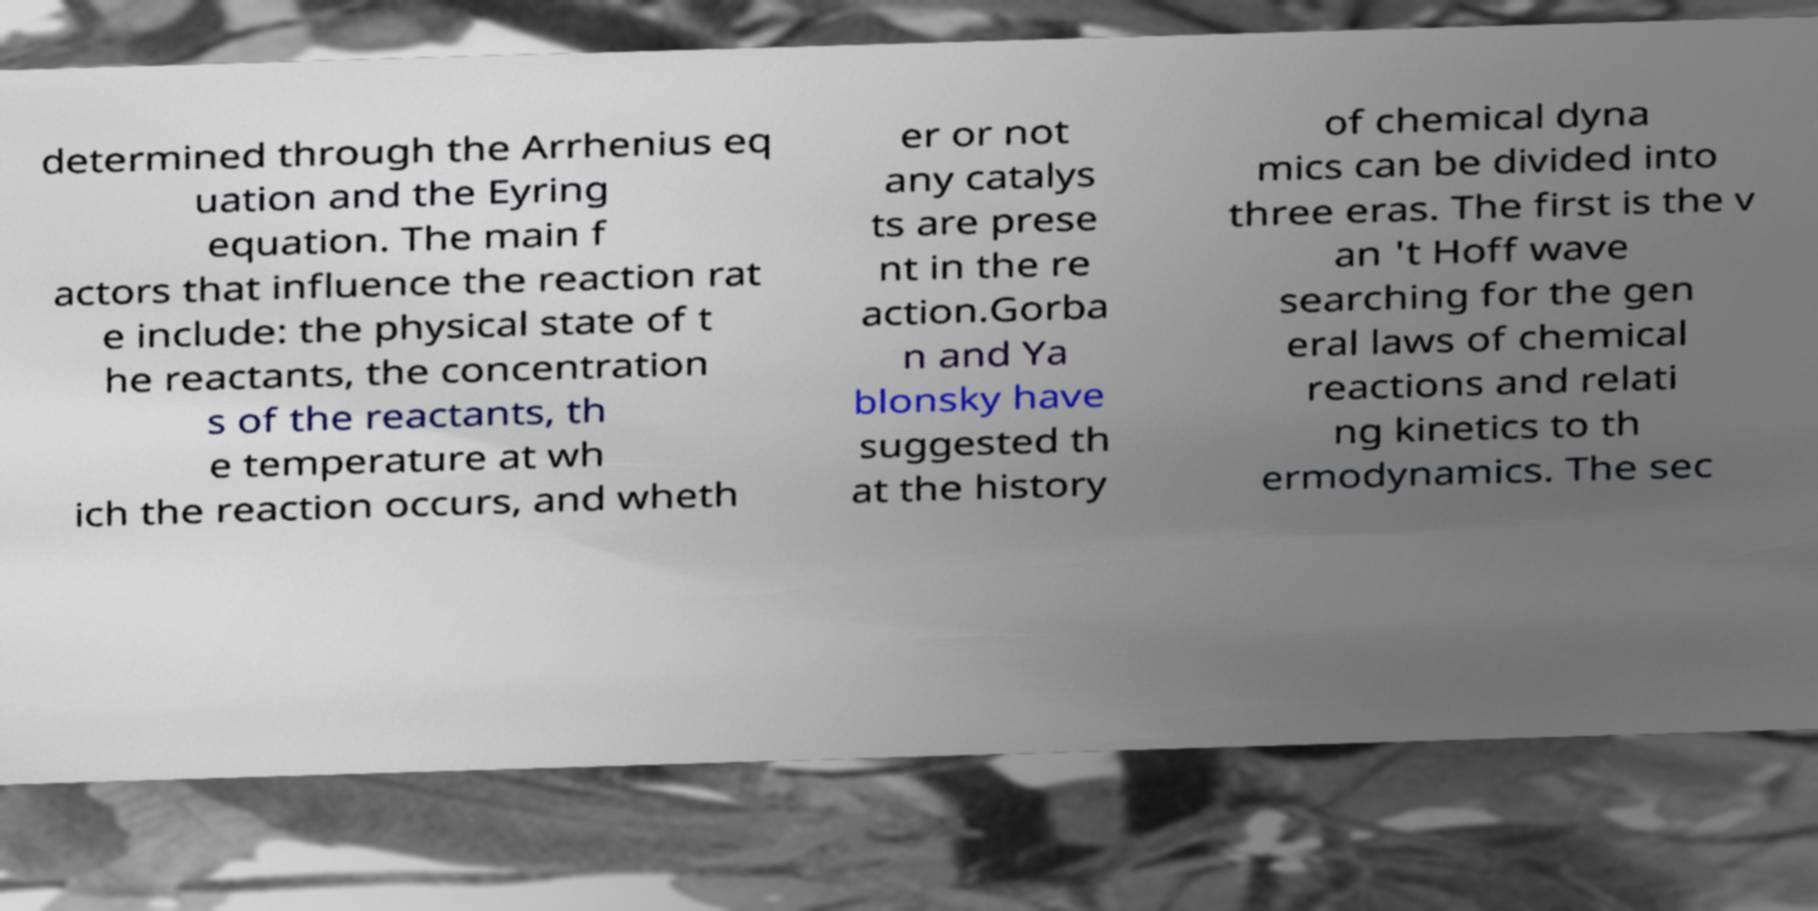Can you accurately transcribe the text from the provided image for me? determined through the Arrhenius eq uation and the Eyring equation. The main f actors that influence the reaction rat e include: the physical state of t he reactants, the concentration s of the reactants, th e temperature at wh ich the reaction occurs, and wheth er or not any catalys ts are prese nt in the re action.Gorba n and Ya blonsky have suggested th at the history of chemical dyna mics can be divided into three eras. The first is the v an 't Hoff wave searching for the gen eral laws of chemical reactions and relati ng kinetics to th ermodynamics. The sec 